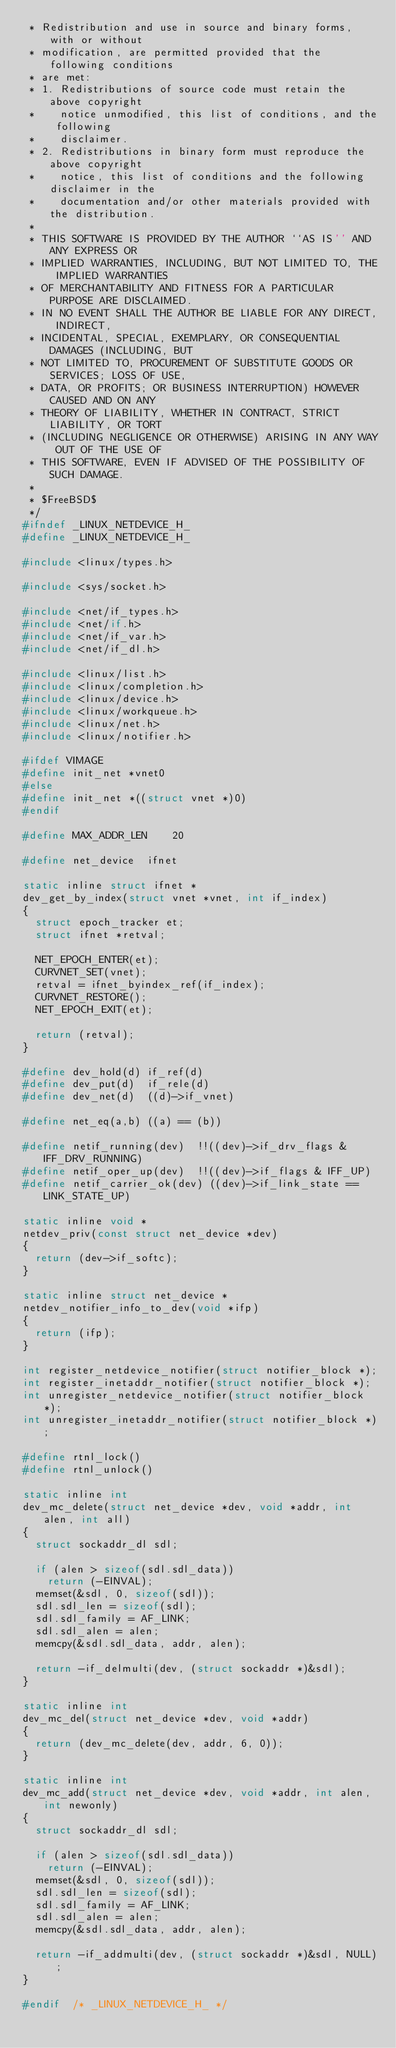<code> <loc_0><loc_0><loc_500><loc_500><_C_> * Redistribution and use in source and binary forms, with or without
 * modification, are permitted provided that the following conditions
 * are met:
 * 1. Redistributions of source code must retain the above copyright
 *    notice unmodified, this list of conditions, and the following
 *    disclaimer.
 * 2. Redistributions in binary form must reproduce the above copyright
 *    notice, this list of conditions and the following disclaimer in the
 *    documentation and/or other materials provided with the distribution.
 *
 * THIS SOFTWARE IS PROVIDED BY THE AUTHOR ``AS IS'' AND ANY EXPRESS OR
 * IMPLIED WARRANTIES, INCLUDING, BUT NOT LIMITED TO, THE IMPLIED WARRANTIES
 * OF MERCHANTABILITY AND FITNESS FOR A PARTICULAR PURPOSE ARE DISCLAIMED.
 * IN NO EVENT SHALL THE AUTHOR BE LIABLE FOR ANY DIRECT, INDIRECT,
 * INCIDENTAL, SPECIAL, EXEMPLARY, OR CONSEQUENTIAL DAMAGES (INCLUDING, BUT
 * NOT LIMITED TO, PROCUREMENT OF SUBSTITUTE GOODS OR SERVICES; LOSS OF USE,
 * DATA, OR PROFITS; OR BUSINESS INTERRUPTION) HOWEVER CAUSED AND ON ANY
 * THEORY OF LIABILITY, WHETHER IN CONTRACT, STRICT LIABILITY, OR TORT
 * (INCLUDING NEGLIGENCE OR OTHERWISE) ARISING IN ANY WAY OUT OF THE USE OF
 * THIS SOFTWARE, EVEN IF ADVISED OF THE POSSIBILITY OF SUCH DAMAGE.
 *
 * $FreeBSD$
 */
#ifndef	_LINUX_NETDEVICE_H_
#define	_LINUX_NETDEVICE_H_

#include <linux/types.h>

#include <sys/socket.h>

#include <net/if_types.h>
#include <net/if.h>
#include <net/if_var.h>
#include <net/if_dl.h>

#include <linux/list.h>
#include <linux/completion.h>
#include <linux/device.h>
#include <linux/workqueue.h>
#include <linux/net.h>
#include <linux/notifier.h>

#ifdef VIMAGE
#define	init_net *vnet0
#else
#define	init_net *((struct vnet *)0)
#endif

#define	MAX_ADDR_LEN		20

#define	net_device	ifnet

static inline struct ifnet *
dev_get_by_index(struct vnet *vnet, int if_index)
{
	struct epoch_tracker et;
	struct ifnet *retval;

	NET_EPOCH_ENTER(et);
	CURVNET_SET(vnet);
	retval = ifnet_byindex_ref(if_index);
	CURVNET_RESTORE();
	NET_EPOCH_EXIT(et);

	return (retval);
}

#define	dev_hold(d)	if_ref(d)
#define	dev_put(d)	if_rele(d)
#define	dev_net(d)	((d)->if_vnet)

#define	net_eq(a,b)	((a) == (b))

#define	netif_running(dev)	!!((dev)->if_drv_flags & IFF_DRV_RUNNING)
#define	netif_oper_up(dev)	!!((dev)->if_flags & IFF_UP)
#define	netif_carrier_ok(dev)	((dev)->if_link_state == LINK_STATE_UP)

static inline void *
netdev_priv(const struct net_device *dev)
{
	return (dev->if_softc);
}

static inline struct net_device *
netdev_notifier_info_to_dev(void *ifp)
{
	return (ifp);
}

int	register_netdevice_notifier(struct notifier_block *);
int	register_inetaddr_notifier(struct notifier_block *);
int	unregister_netdevice_notifier(struct notifier_block *);
int	unregister_inetaddr_notifier(struct notifier_block *);

#define	rtnl_lock()
#define	rtnl_unlock()

static inline int
dev_mc_delete(struct net_device *dev, void *addr, int alen, int all)
{
	struct sockaddr_dl sdl;

	if (alen > sizeof(sdl.sdl_data))
		return (-EINVAL);
	memset(&sdl, 0, sizeof(sdl));
	sdl.sdl_len = sizeof(sdl);
	sdl.sdl_family = AF_LINK;
	sdl.sdl_alen = alen;
	memcpy(&sdl.sdl_data, addr, alen);

	return -if_delmulti(dev, (struct sockaddr *)&sdl);
}

static inline int
dev_mc_del(struct net_device *dev, void *addr)
{
	return (dev_mc_delete(dev, addr, 6, 0));
}

static inline int
dev_mc_add(struct net_device *dev, void *addr, int alen, int newonly)
{
	struct sockaddr_dl sdl;

	if (alen > sizeof(sdl.sdl_data))
		return (-EINVAL);
	memset(&sdl, 0, sizeof(sdl));
	sdl.sdl_len = sizeof(sdl);
	sdl.sdl_family = AF_LINK;
	sdl.sdl_alen = alen;
	memcpy(&sdl.sdl_data, addr, alen);

	return -if_addmulti(dev, (struct sockaddr *)&sdl, NULL);
}

#endif	/* _LINUX_NETDEVICE_H_ */
</code> 